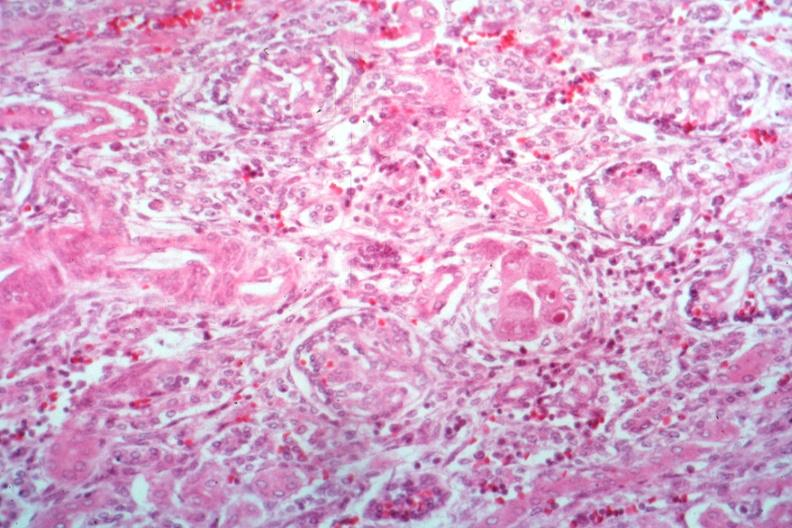what is present?
Answer the question using a single word or phrase. Cytomegalovirus 